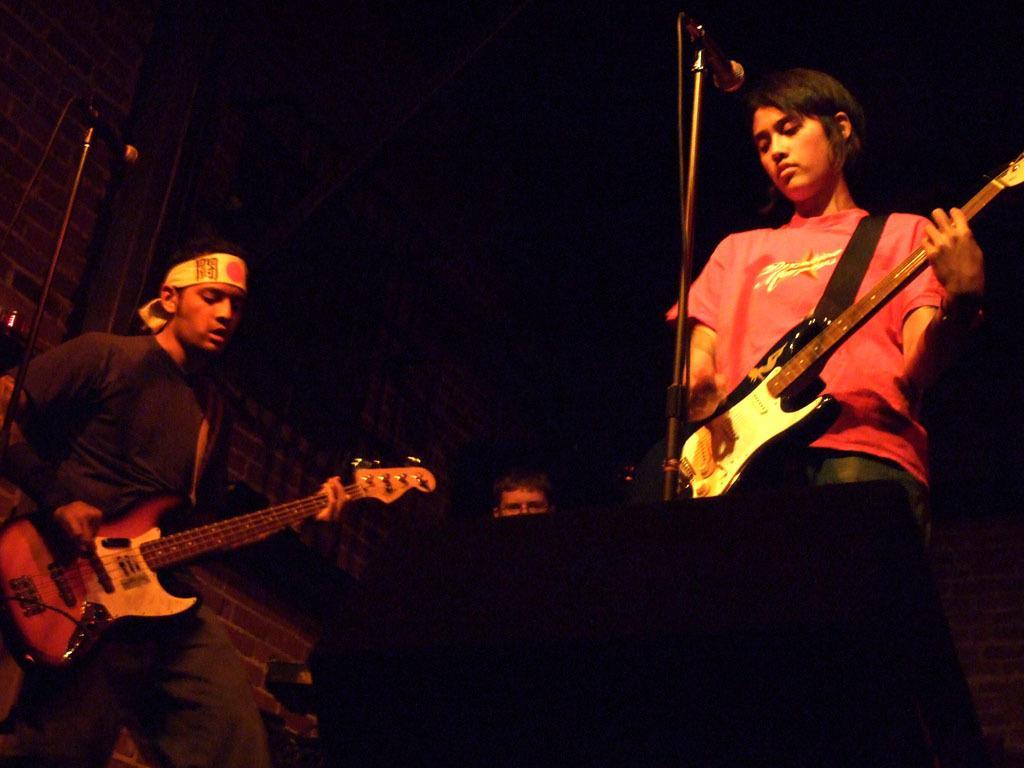Describe this image in one or two sentences. In this image there are a few people standing and playing musical instruments, in front of them there are mic´s. The background is dark. 